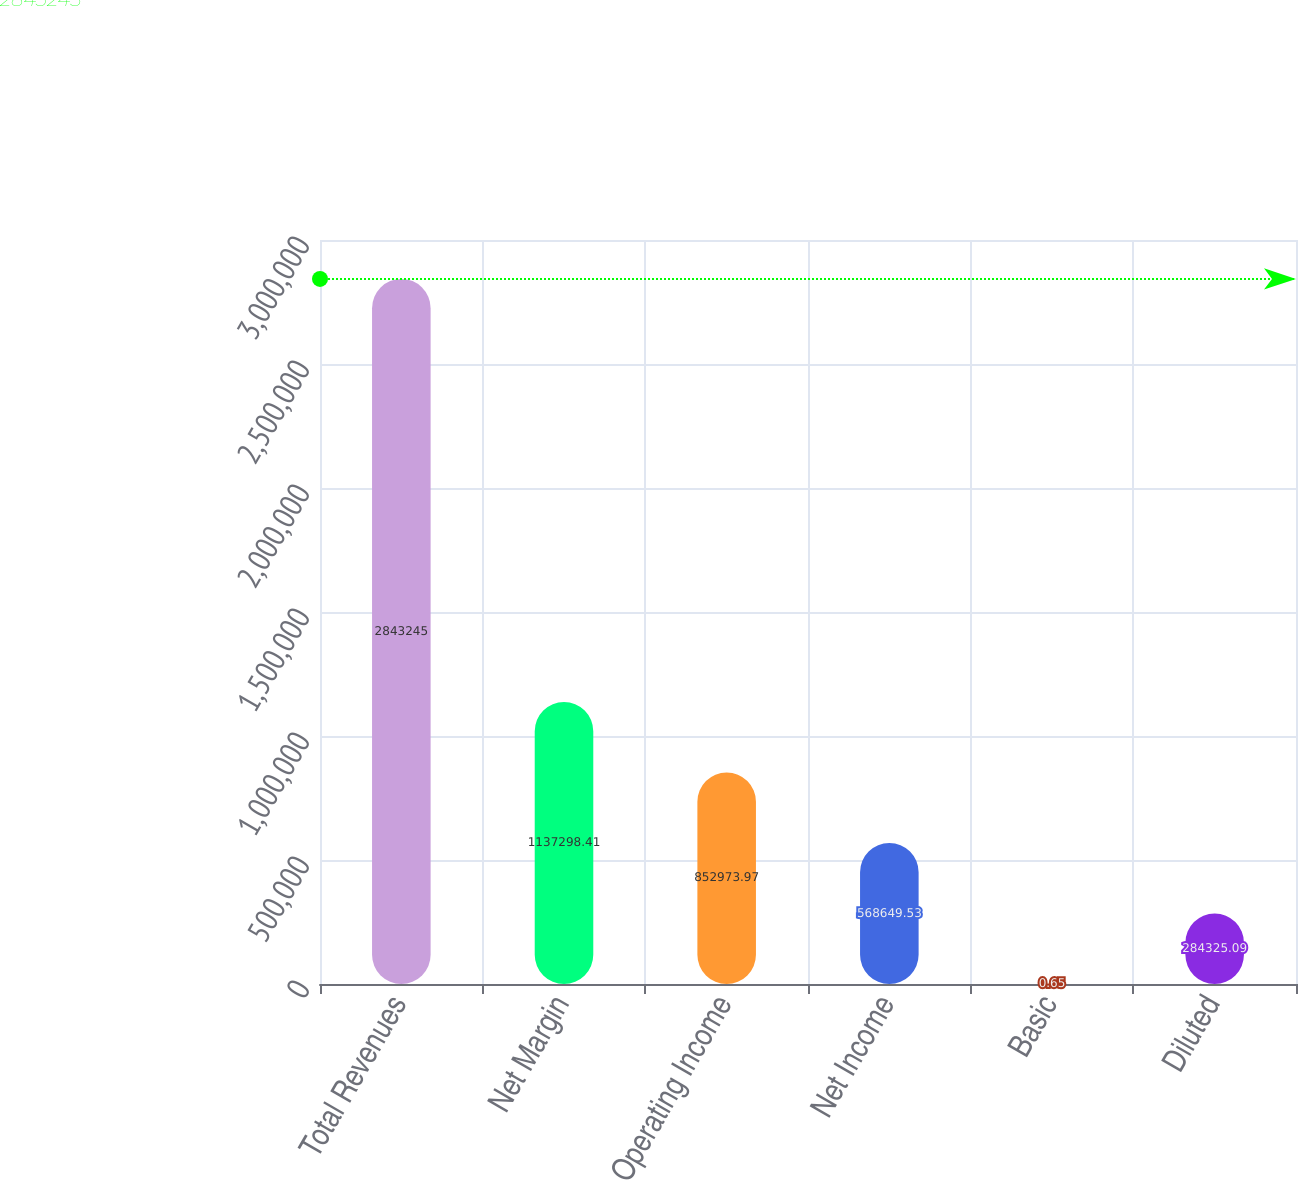Convert chart. <chart><loc_0><loc_0><loc_500><loc_500><bar_chart><fcel>Total Revenues<fcel>Net Margin<fcel>Operating Income<fcel>Net Income<fcel>Basic<fcel>Diluted<nl><fcel>2.84324e+06<fcel>1.1373e+06<fcel>852974<fcel>568650<fcel>0.65<fcel>284325<nl></chart> 